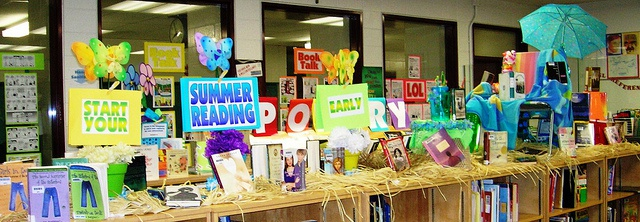Describe the objects in this image and their specific colors. I can see book in black, lightgray, olive, and tan tones, umbrella in black, teal, and turquoise tones, book in black, violet, blue, and lavender tones, book in black, lightgray, lightgreen, and green tones, and book in black, ivory, khaki, tan, and purple tones in this image. 